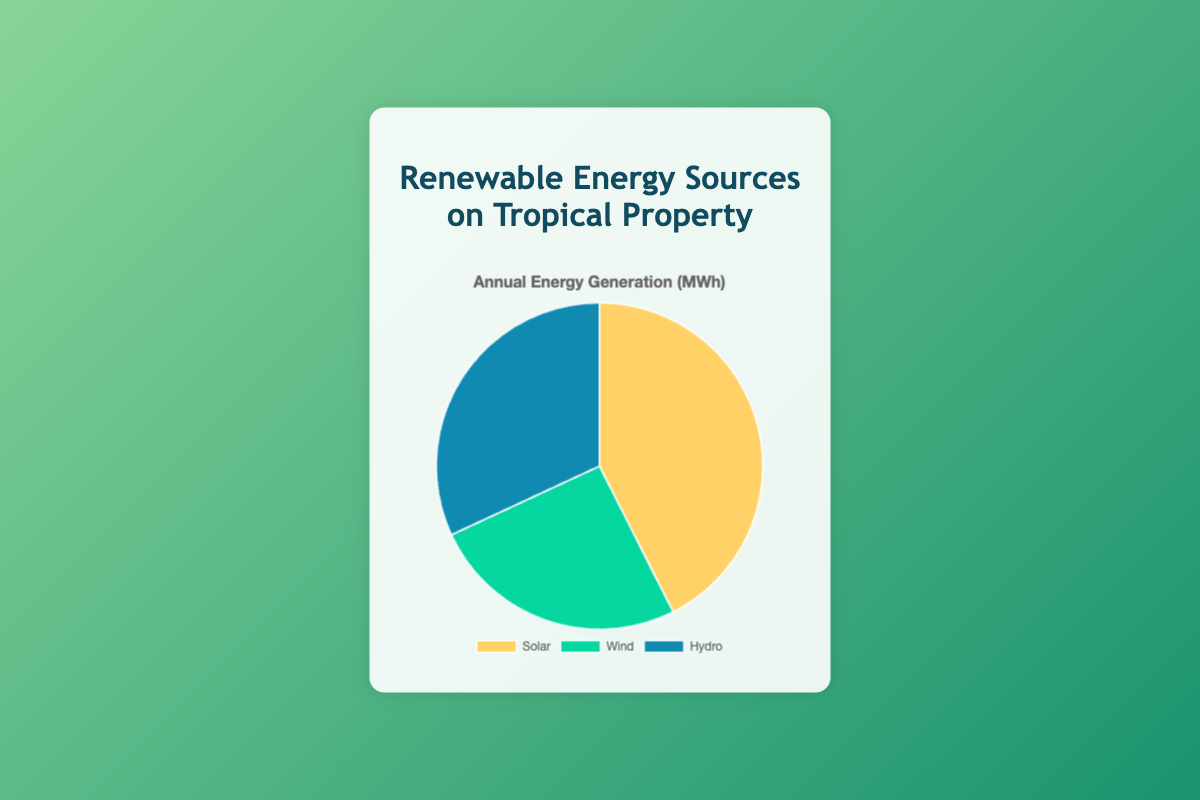What are the total annual generation values of Solar and Wind combined? To find the total annual generation values of Solar and Wind, add their individual values: Solar generates 200 MWh and Wind generates 120 MWh. So, 200 MWh + 120 MWh = 320 MWh.
Answer: 320 MWh Which energy source has the highest annual generation? From the pie chart, it is clear that Solar has 200 MWh, which is higher than Wind (120 MWh) and Hydro (150 MWh). Therefore, Solar has the highest annual generation.
Answer: Solar What is the difference between the annual generation values of Solar and Hydro? To find the difference between the annual generation of Solar and Hydro, subtract Hydro's generation from Solar's: 200 MWh - 150 MWh = 50 MWh.
Answer: 50 MWh Which energy source is represented by the green color in the pie chart? From the visual attributes in the pie chart, green color represents the Wind energy source.
Answer: Wind How much more does Solar generate annually compared to Wind? Solar generates 200 MWh and Wind generates 120 MWh. The difference can be calculated as 200 MWh - 120 MWh = 80 MWh. So, Solar generates 80 MWh more annually than Wind.
Answer: 80 MWh What is the sum of the annual generation values of all three energy sources? The total annual generation is the sum of Solar, Wind, and Hydro: 200 MWh + 120 MWh + 150 MWh = 470 MWh.
Answer: 470 MWh 